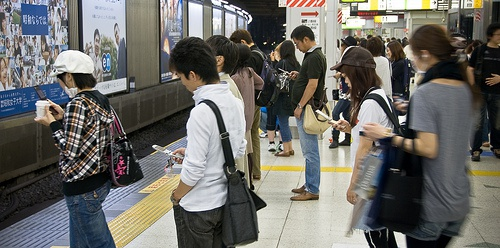Describe the objects in this image and their specific colors. I can see people in black, gray, and tan tones, people in black, lightgray, darkgray, and gray tones, people in black, gray, darkblue, and lightgray tones, people in black, lightgray, gray, and darkgray tones, and people in black and gray tones in this image. 